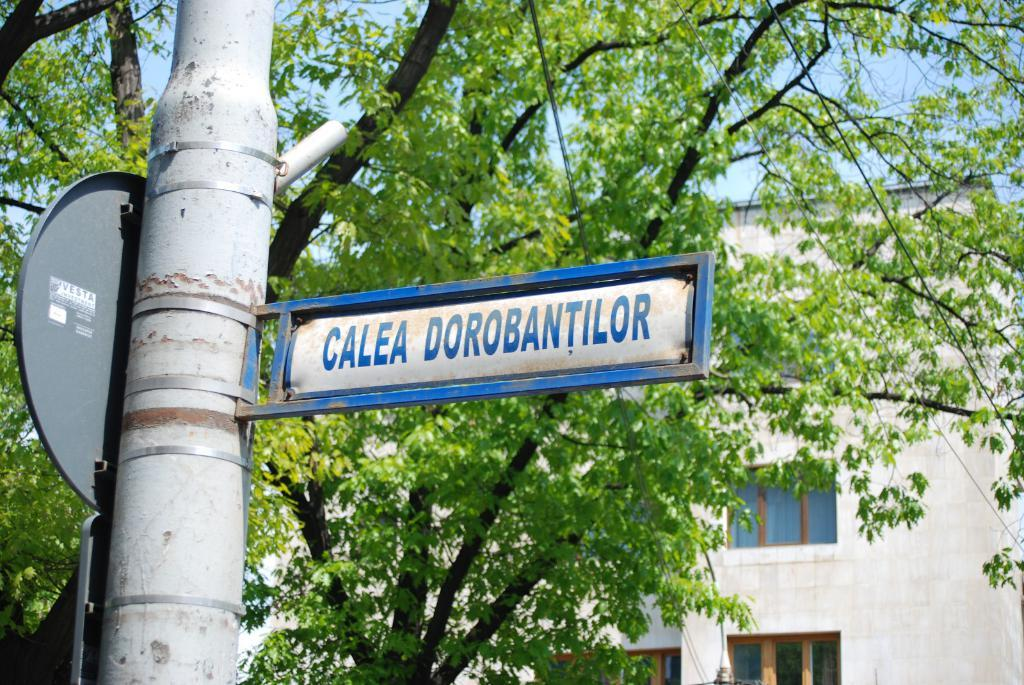<image>
Create a compact narrative representing the image presented. Sign that says Calea Dorobantilor in blue and white 